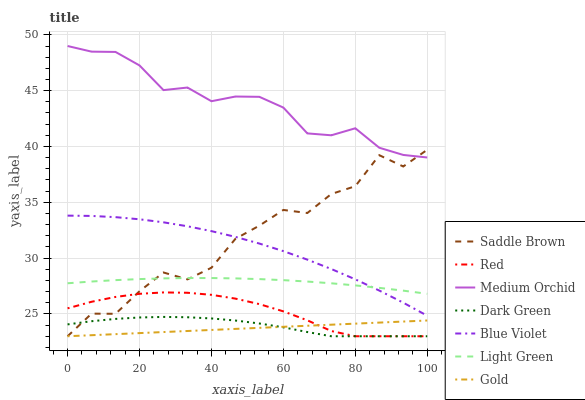Does Gold have the minimum area under the curve?
Answer yes or no. Yes. Does Medium Orchid have the maximum area under the curve?
Answer yes or no. Yes. Does Red have the minimum area under the curve?
Answer yes or no. No. Does Red have the maximum area under the curve?
Answer yes or no. No. Is Gold the smoothest?
Answer yes or no. Yes. Is Saddle Brown the roughest?
Answer yes or no. Yes. Is Medium Orchid the smoothest?
Answer yes or no. No. Is Medium Orchid the roughest?
Answer yes or no. No. Does Medium Orchid have the lowest value?
Answer yes or no. No. Does Red have the highest value?
Answer yes or no. No. Is Dark Green less than Medium Orchid?
Answer yes or no. Yes. Is Blue Violet greater than Gold?
Answer yes or no. Yes. Does Dark Green intersect Medium Orchid?
Answer yes or no. No. 